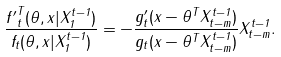<formula> <loc_0><loc_0><loc_500><loc_500>\frac { { f ^ { \prime } } _ { t } ^ { T } ( \theta , x | X _ { 1 } ^ { t - 1 } ) } { f _ { t } ( \theta , x | X _ { 1 } ^ { t - 1 } ) } = - \frac { g _ { t } ^ { \prime } ( x - \theta ^ { T } X _ { t - m } ^ { t - 1 } ) } { g _ { t } ( x - \theta ^ { T } X _ { t - m } ^ { t - 1 } ) } X _ { t - m } ^ { t - 1 } .</formula> 